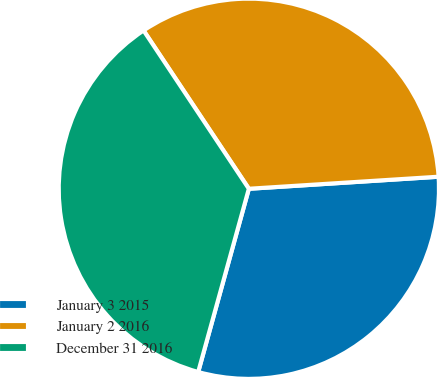Convert chart to OTSL. <chart><loc_0><loc_0><loc_500><loc_500><pie_chart><fcel>January 3 2015<fcel>January 2 2016<fcel>December 31 2016<nl><fcel>30.3%<fcel>33.33%<fcel>36.36%<nl></chart> 